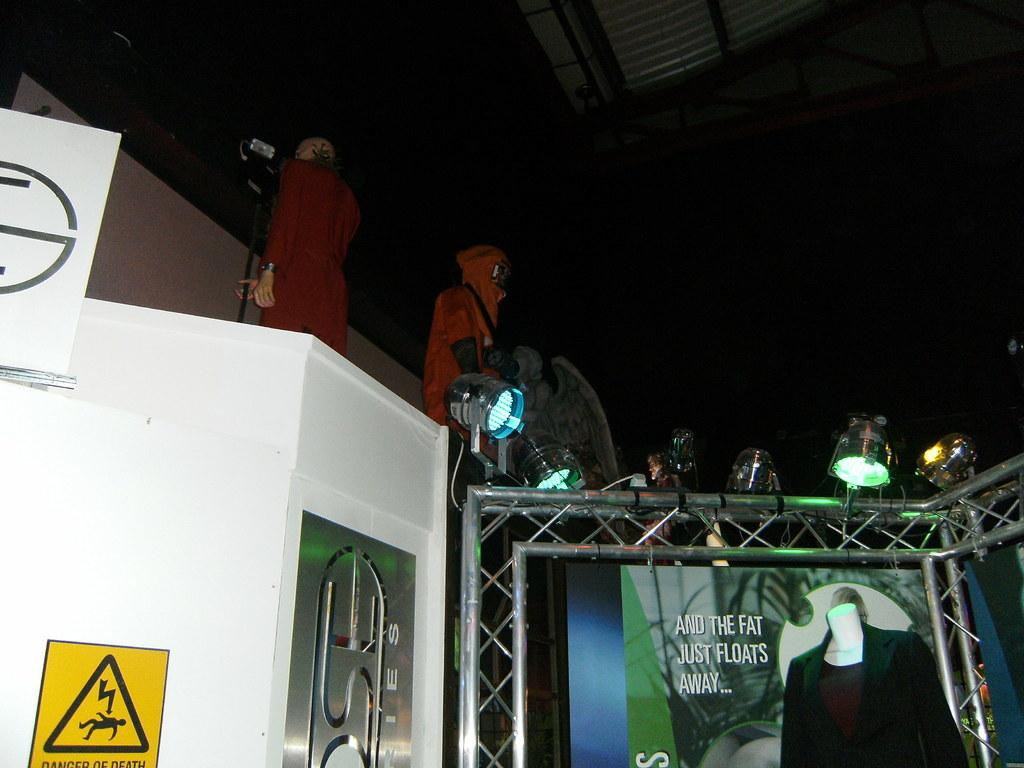Who or what is present in the image? There are people in the image. What are the people wearing? The people are wearing clothes. What are the people doing in the image? The people are standing. What type of image is it? The image is a poster. What else can be seen in the image besides the people? There are lights and a board in the image. What type of cherry is being used to support the board in the image? There is no cherry present in the image, and the board is not being supported by any fruit. 